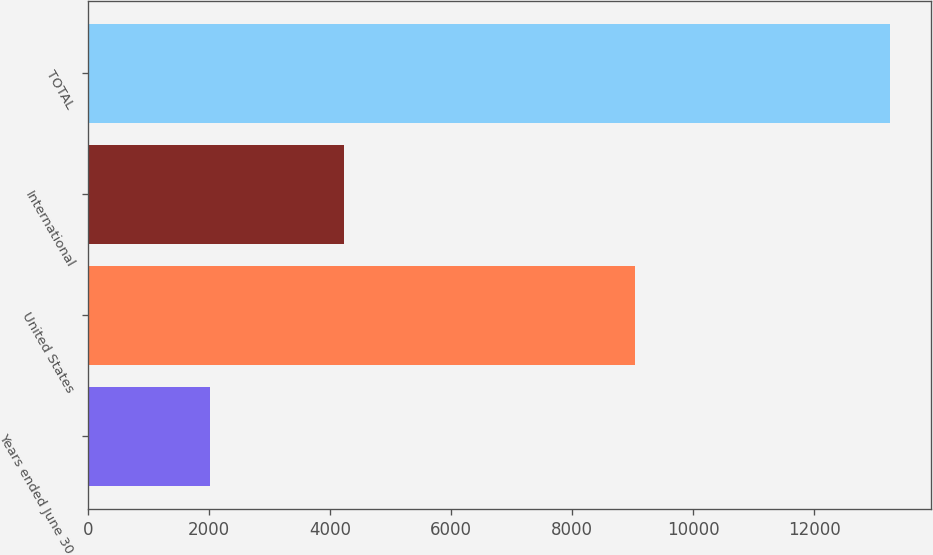Convert chart. <chart><loc_0><loc_0><loc_500><loc_500><bar_chart><fcel>Years ended June 30<fcel>United States<fcel>International<fcel>TOTAL<nl><fcel>2017<fcel>9031<fcel>4226<fcel>13257<nl></chart> 